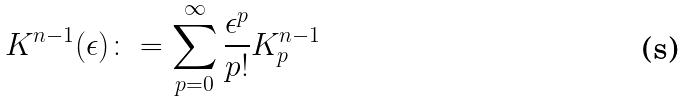<formula> <loc_0><loc_0><loc_500><loc_500>K ^ { n - 1 } ( \epsilon ) \colon = \sum _ { p = 0 } ^ { \infty } \frac { \epsilon ^ { p } } { p ! } K ^ { n - 1 } _ { p }</formula> 